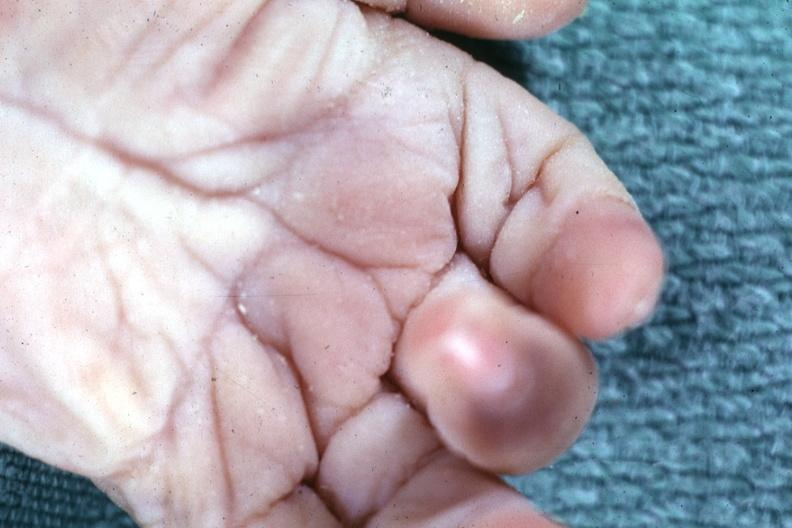what are present?
Answer the question using a single word or phrase. Extremities 